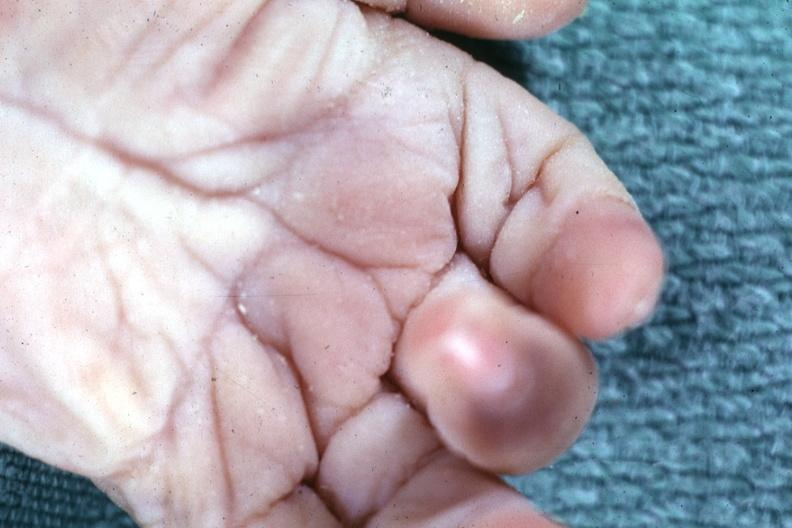what are present?
Answer the question using a single word or phrase. Extremities 